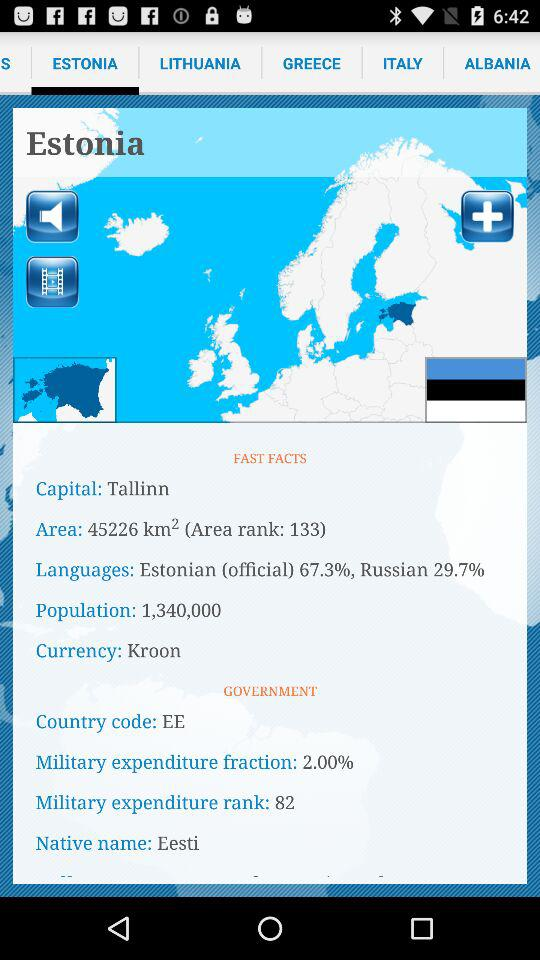What is the military's expenditure fraction? The military's expenditure fraction is 2%. 